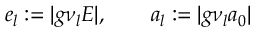<formula> <loc_0><loc_0><loc_500><loc_500>e _ { l } \colon = | g \nu _ { l } E | , \quad a _ { l } \colon = | g \nu _ { l } a _ { 0 } |</formula> 